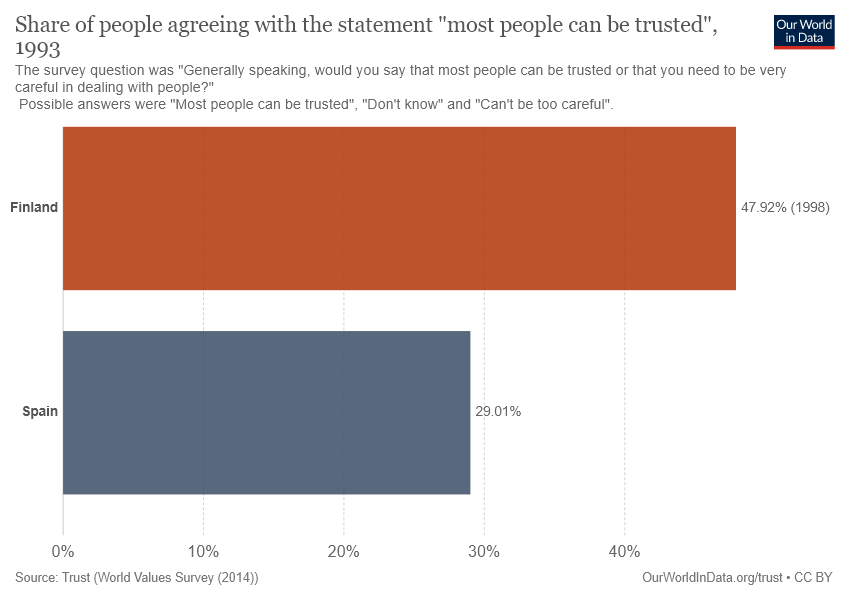Draw attention to some important aspects in this diagram. The graph mentions two places: Finland and Spain. There are two color bars displayed in the graph. 